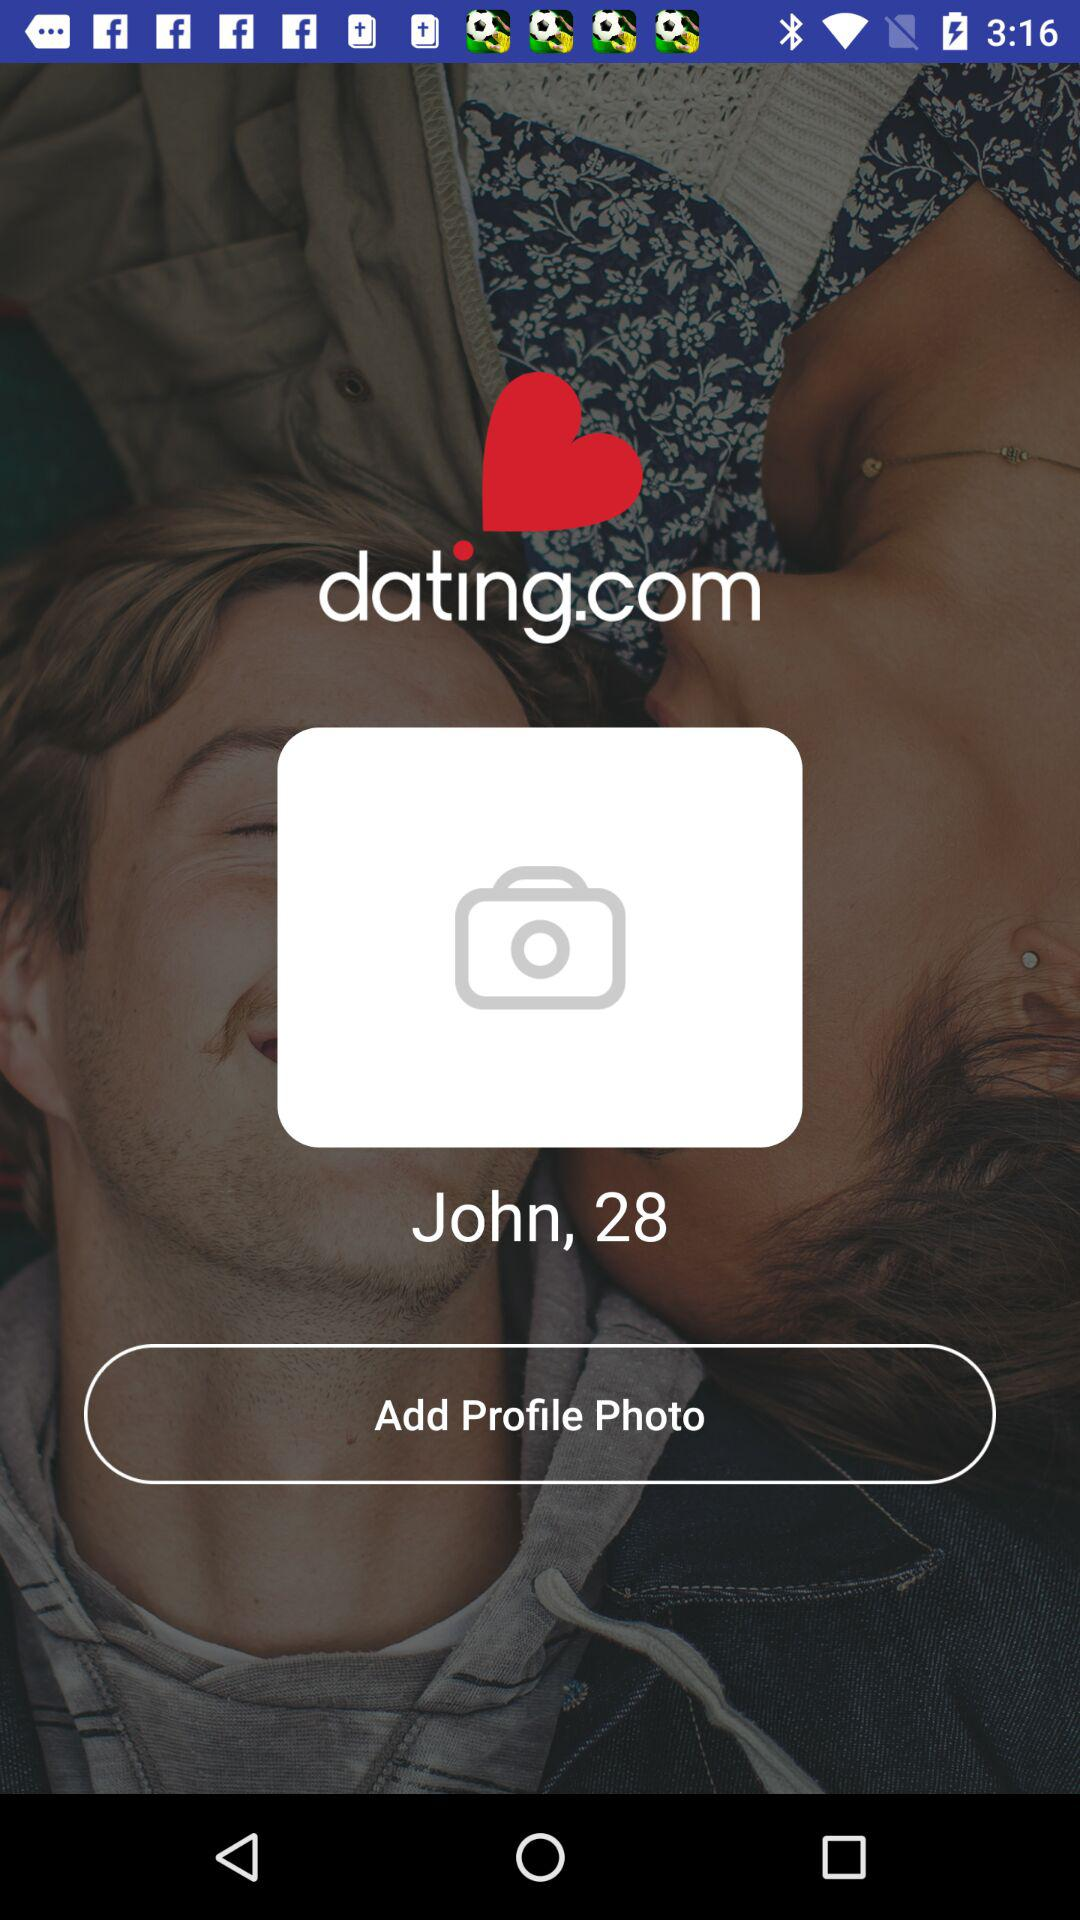What is the age of John? The age of John is 28. 